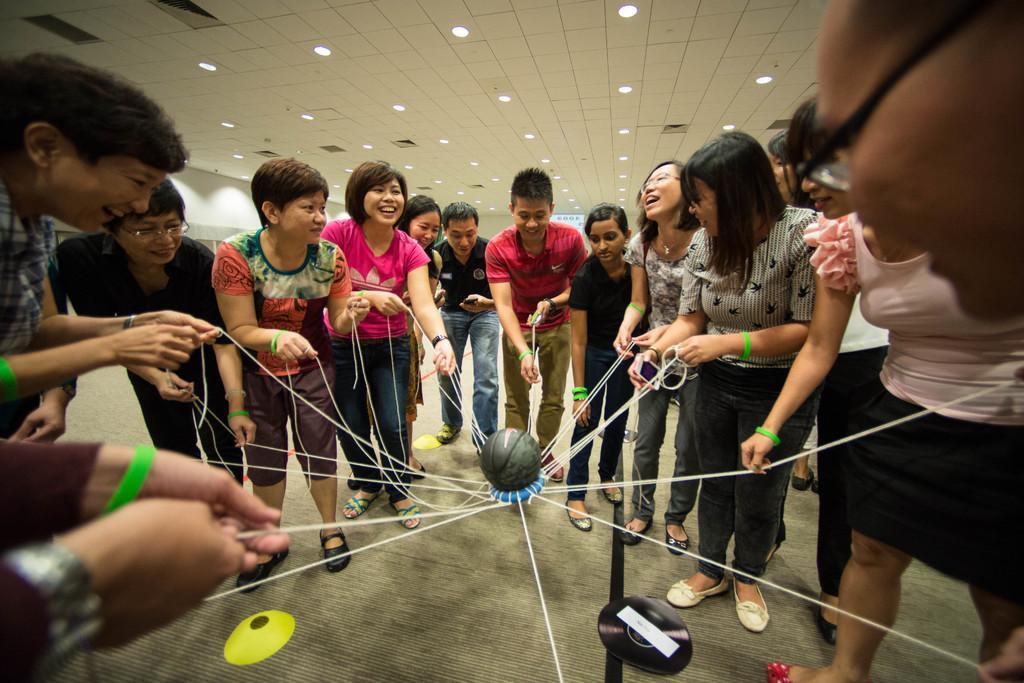Describe this image in one or two sentences. In this image we can see people smiling and standing on the floor and also holding the threads of an object which is having the ball. We can also see the ceiling with the lights. There is an object on the floor. 